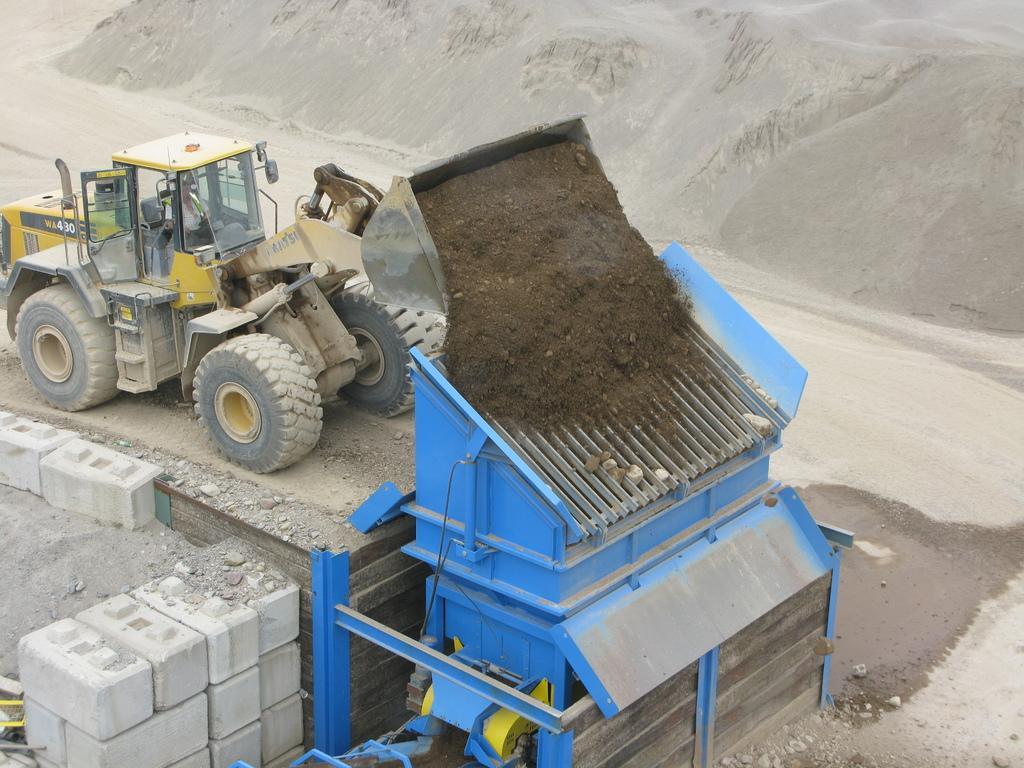How would you summarize this image in a sentence or two? In this picture there is a blue color machine. Behind there is a yellow color excavator putting a sand on the blue color machine. On the left side of the image there are some concrete blocks. On the right side we can see the crush power sand. 